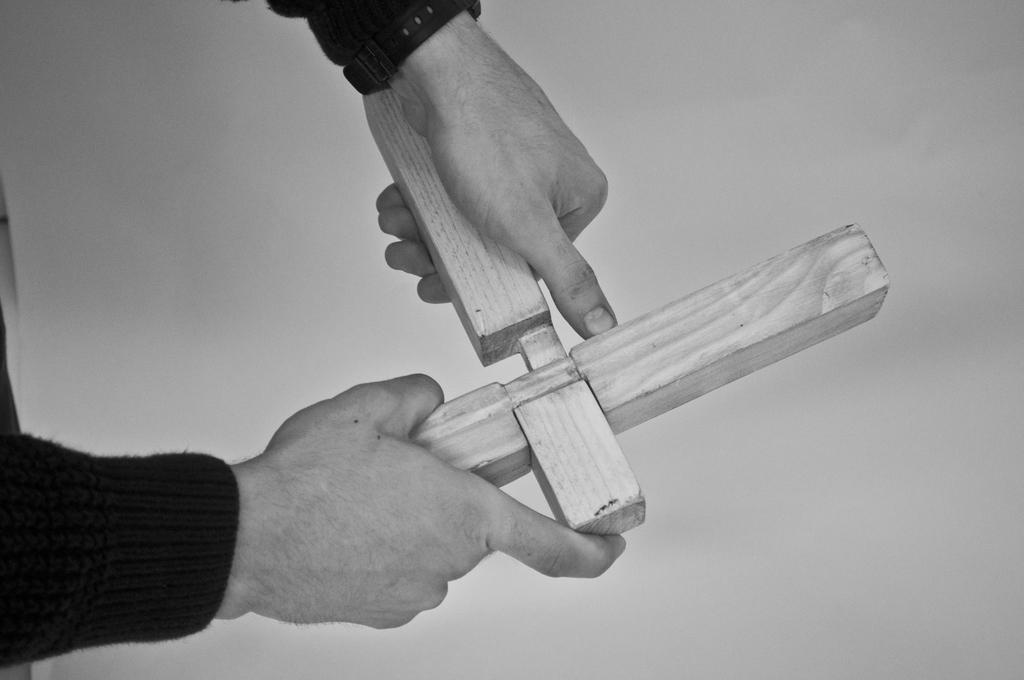What body part is visible in the image? The hands of a person are visible in the image. What are the hands holding? The hands are holding a wooden object. What type of root can be seen growing near the person's hands in the image? There is no root visible in the image; only the hands and the wooden object are present. What actor is performing with the wooden object in the image? There is no actor or performance depicted in the image; it simply shows a person's hands holding a wooden object. 